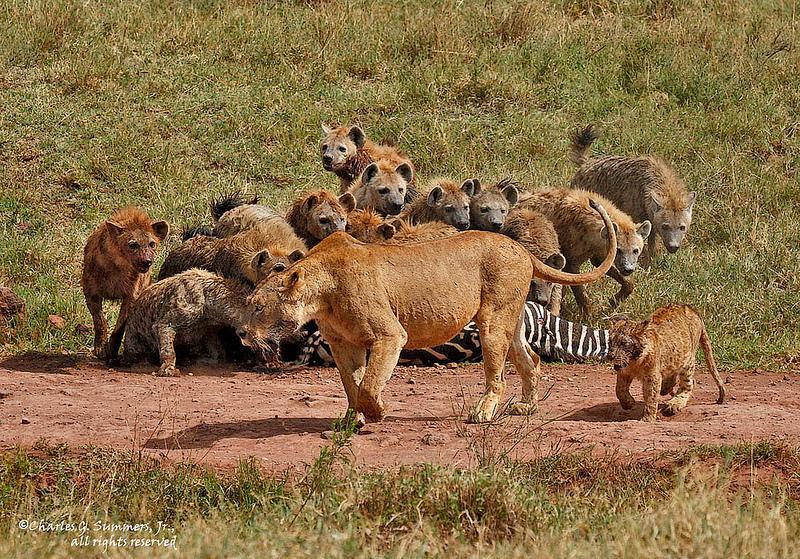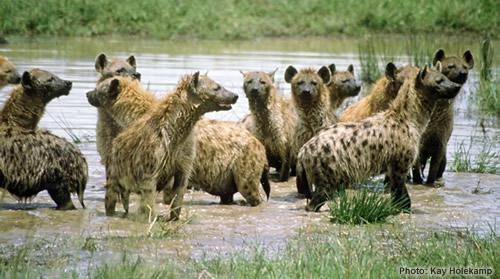The first image is the image on the left, the second image is the image on the right. Assess this claim about the two images: "One group of animals is standing in the water.". Correct or not? Answer yes or no. Yes. 